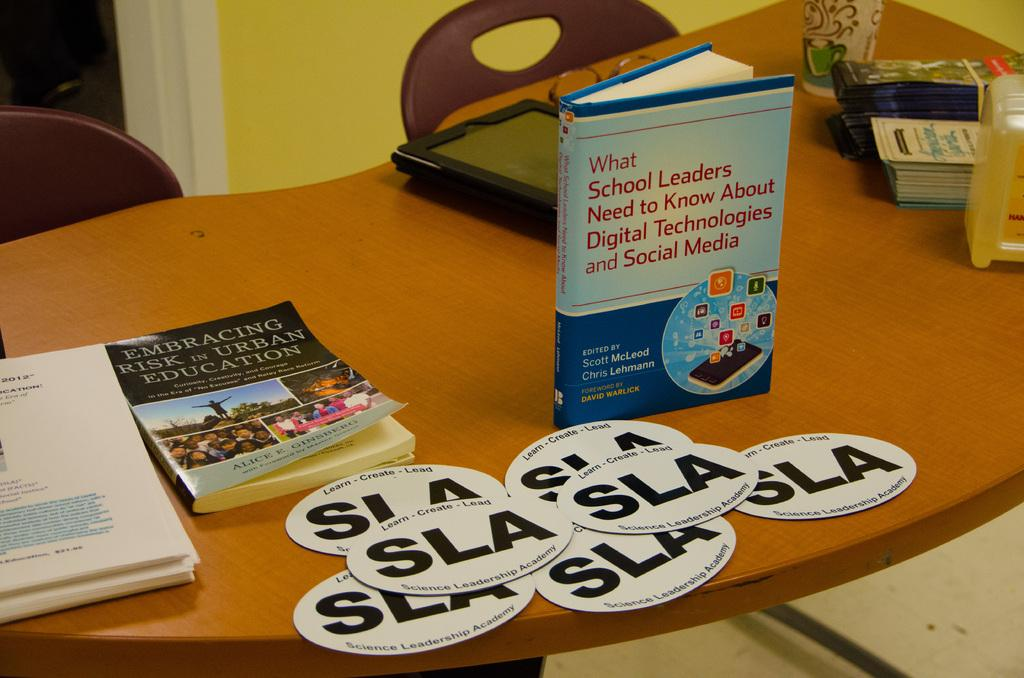<image>
Summarize the visual content of the image. SLA logo on a table and a book about Embracing Risk in Urban Education. 